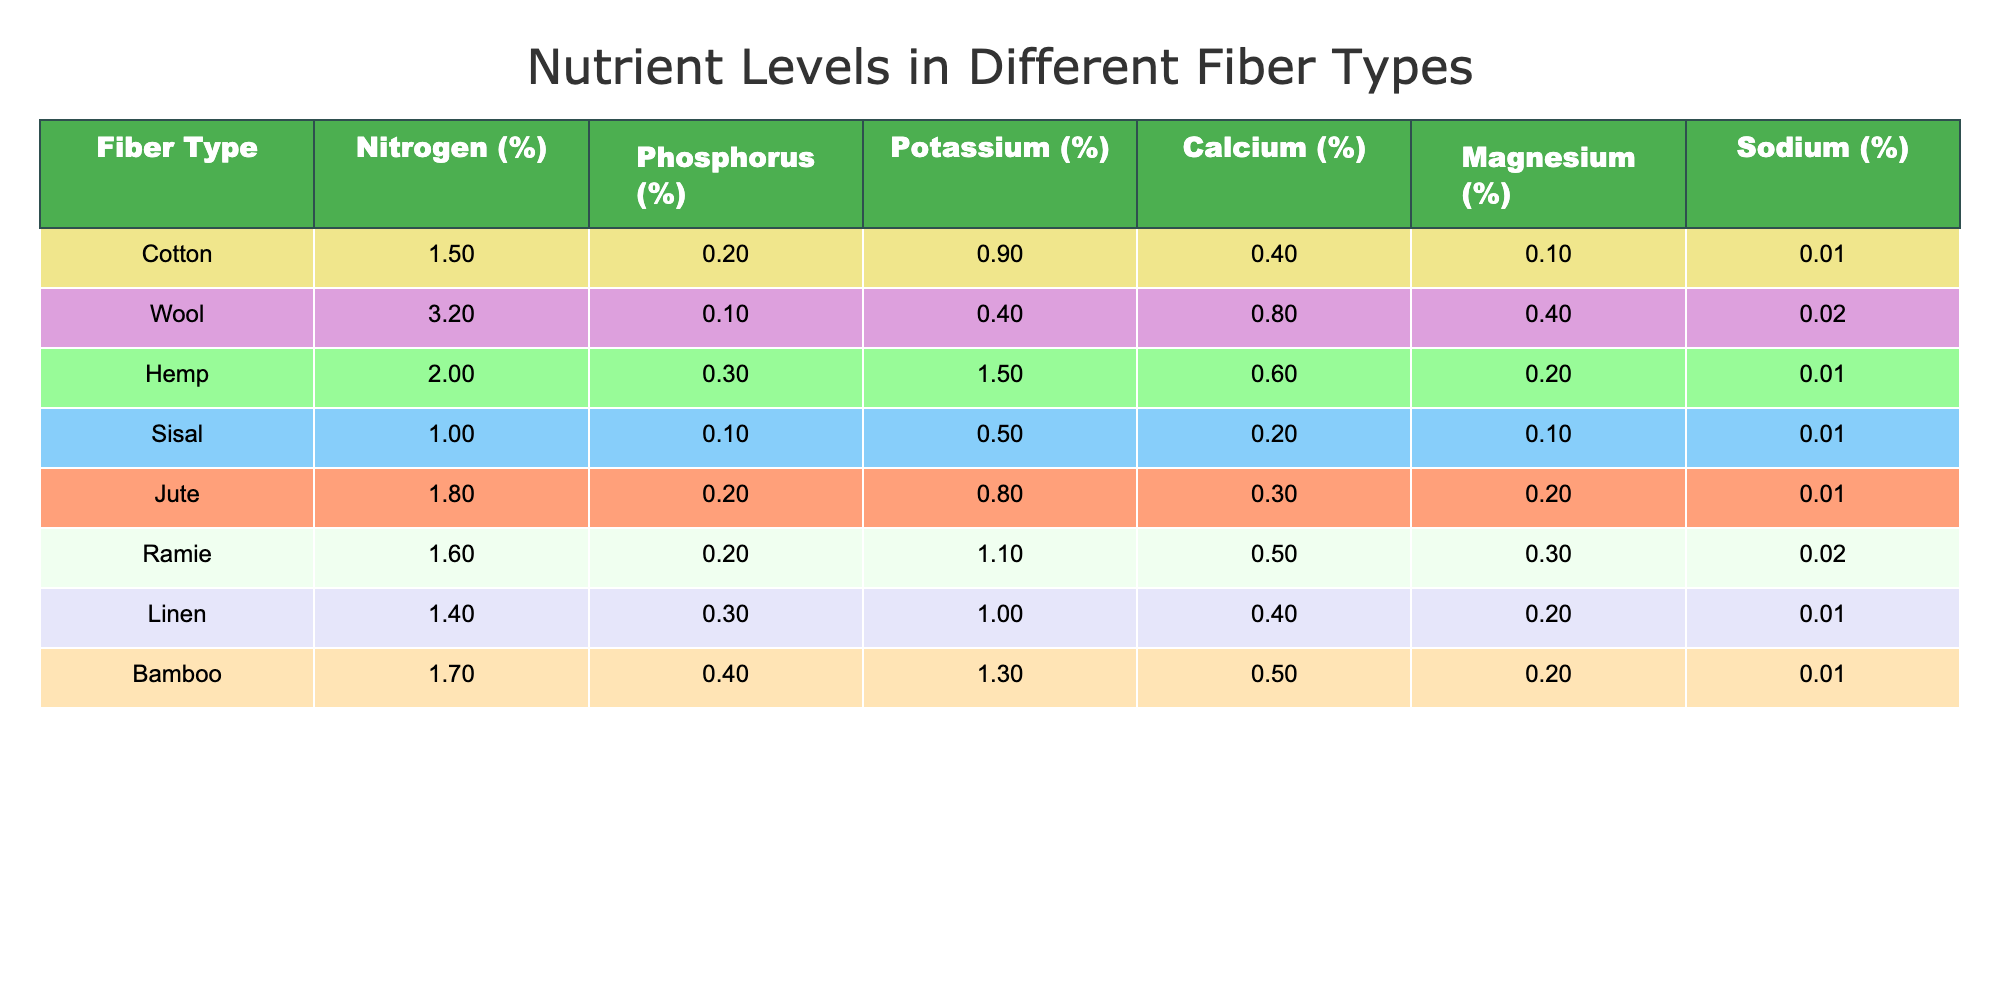What is the nitrogen percentage in wool? From the table, the nitrogen percentage specifically for wool is noted in the second column. It shows a value of 3.2%.
Answer: 3.2% Which fiber type contains the highest level of potassium? Looking across the potassium column, we identify the maximum value by comparing all the entries. Hemp has the highest potassium level at 1.5%.
Answer: Hemp What is the average calcium percentage across all fiber types? To calculate the average calcium percentage, first sum all the calcium values: (0.4 + 0.8 + 0.6 + 0.2 + 0.3 + 0.5 + 0.4 + 0.5) = 3.3. Then, divide by the number of fiber types (8): 3.3/8 = 0.4125. Rounded to two decimal places, the average is approximately 0.41%.
Answer: 0.41% Is jute richer in phosphorus than sisal? From the phosphorus column, we see that jute has a value of 0.2%, while sisal also has 0.1%. Since 0.2% is more than 0.1%, it confirms that jute is richer.
Answer: Yes Which fiber type has the lowest magnesium level, and what is that level? Examining the magnesium column, the values show that sisal has the lowest magnesium level at 0.1%. We confirm this by comparing it to all other entries.
Answer: Sisal, 0.1% What is the percentage difference in nitrogen levels between cotton and ramie? The nitrogen level for cotton is 1.5% and for ramie is 1.6%. The percentage difference can be calculated by taking the absolute value of the difference (1.6 - 1.5 = 0.1) and dividing it by the average of both values: (0.1 / ((1.5 + 1.6)/2)) * 100 = (0.1 / 1.55) * 100 = 6.45%. So, the percentage difference is about 6.45%.
Answer: 6.45% Does bamboo have a higher nitrogen level than linen? Comparing the nitrogen levels, bamboo is at 1.7% and linen is at 1.4%. Since 1.7% is greater than 1.4%, the statement holds true that bamboo has a higher nitrogen level.
Answer: Yes What is the total potassium level for all fiber types combined? To find the total potassium level, sum all the potassium values from the table: (0.9 + 0.4 + 1.5 + 0.5 + 0.8 + 1.1 + 1.0 + 1.3) = 7.5%. Therefore, the total potassium level across all fiber types is 7.5%.
Answer: 7.5% 